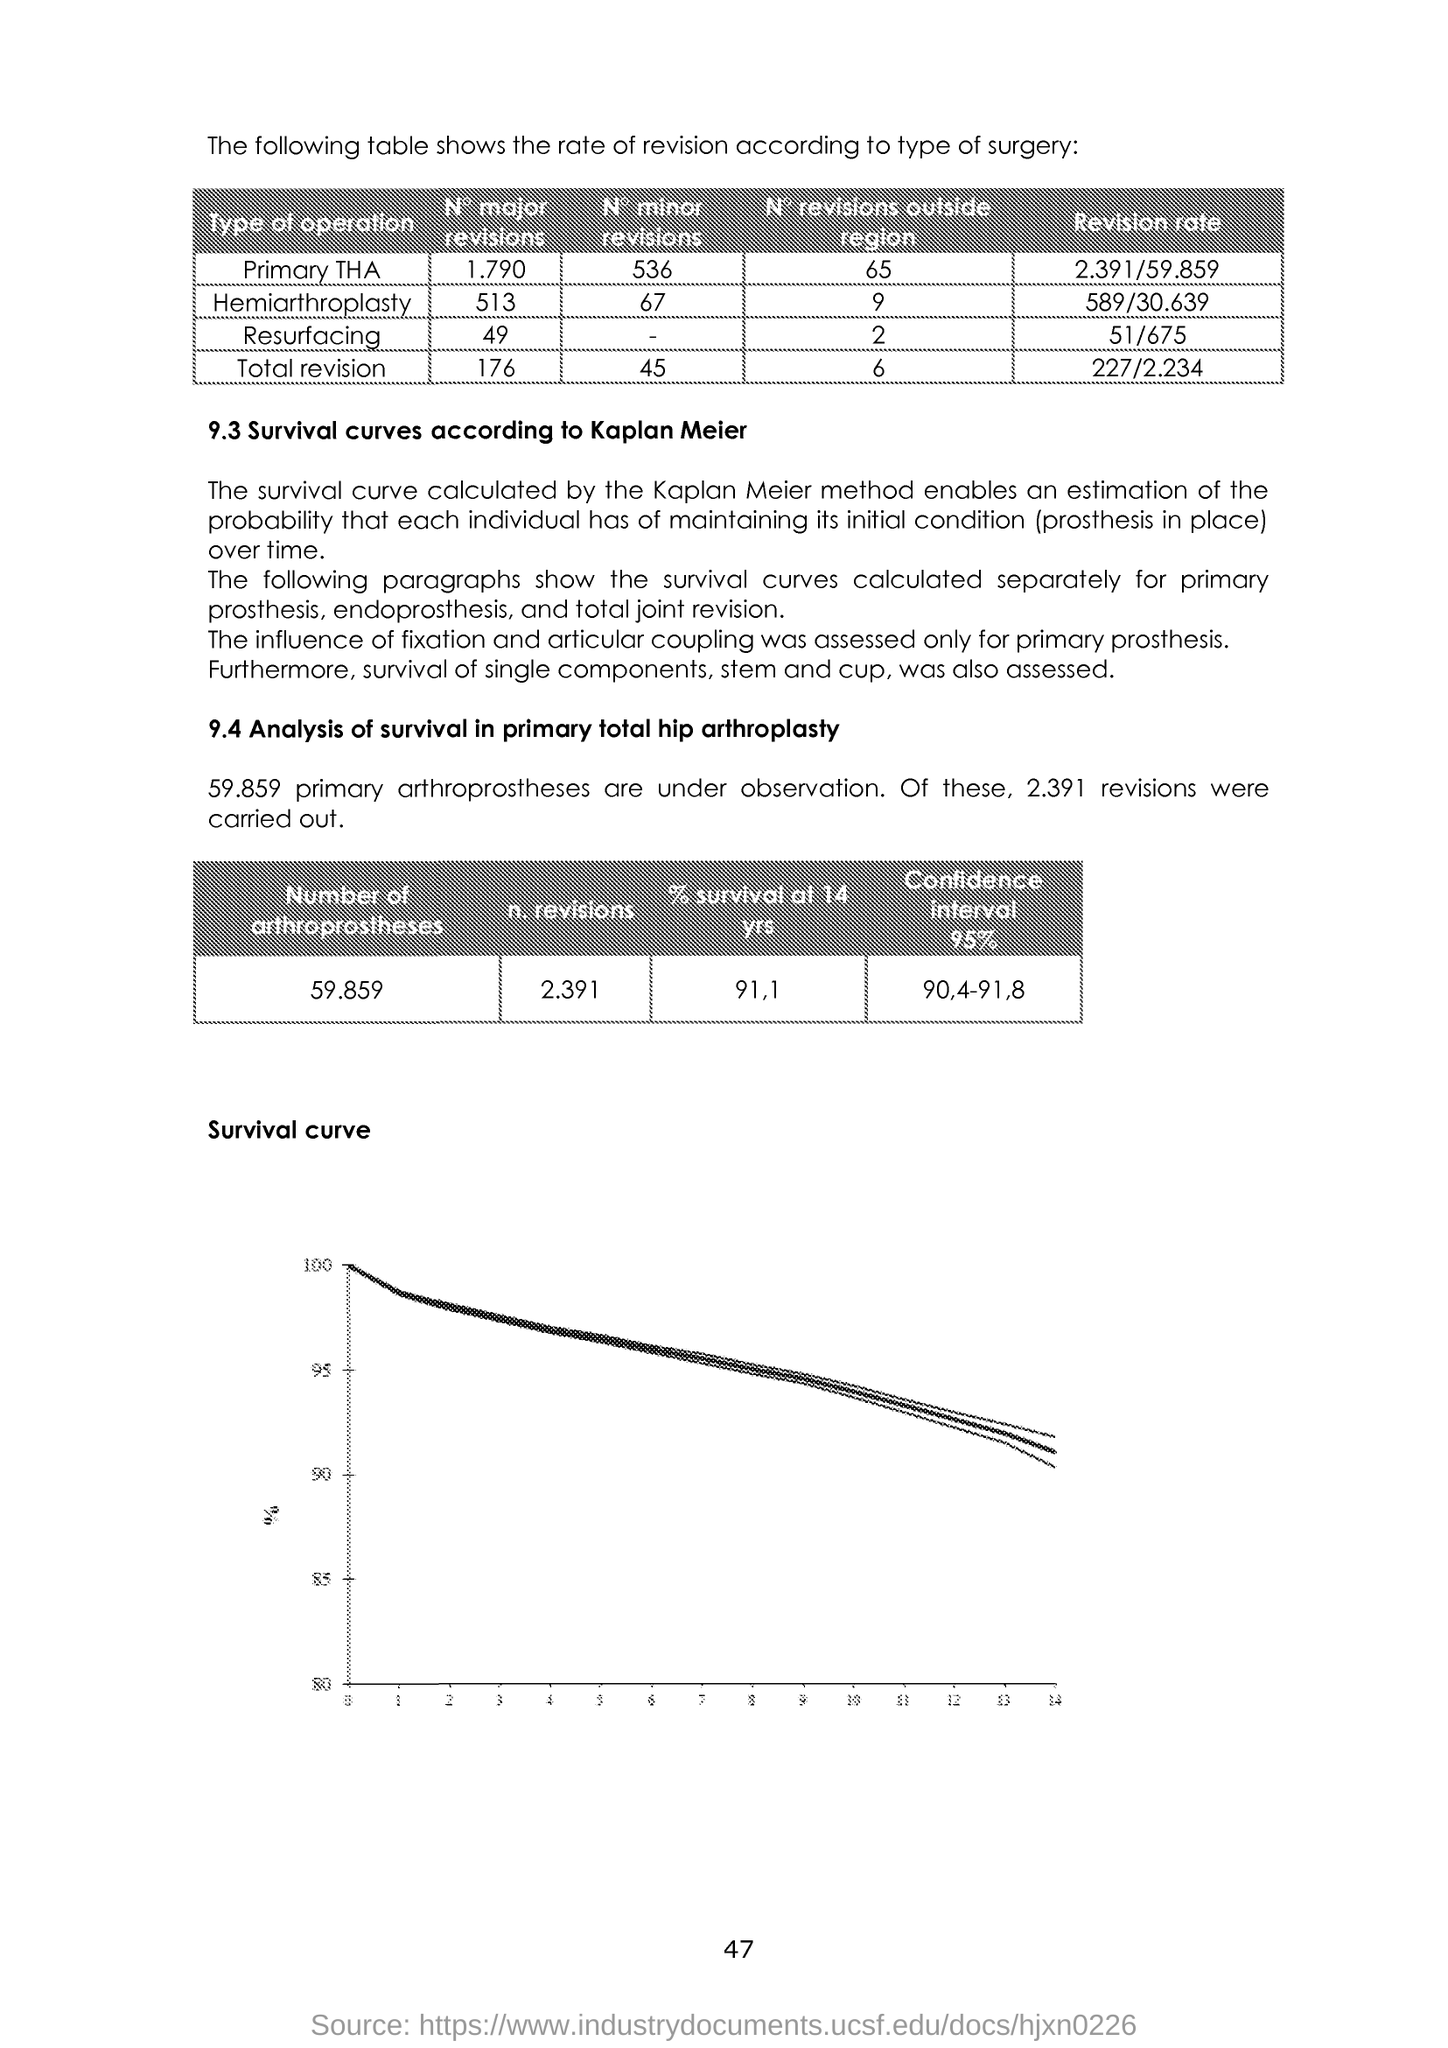Give some essential details in this illustration. The revision rate for resurfacing, as specified in the table, is 51 out of 675. The analysis underwent 2.391 revisions. The title of the graph shown is "Survival Curve. The revision rate for primary total hip arthroplasty (THA) is 2 out of 59 outpatients, with 391 of those patients being revised due to aseptic loosening. The influence of fixation and articular coupling was assessed specifically for primary prostheses 